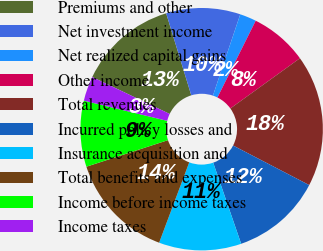Convert chart. <chart><loc_0><loc_0><loc_500><loc_500><pie_chart><fcel>Premiums and other<fcel>Net investment income<fcel>Net realized capital gains<fcel>Other income<fcel>Total revenues<fcel>Incurred policy losses and<fcel>Insurance acquisition and<fcel>Total benefits and expenses<fcel>Income before income taxes<fcel>Income taxes<nl><fcel>13.19%<fcel>9.89%<fcel>2.2%<fcel>7.69%<fcel>17.58%<fcel>12.09%<fcel>10.99%<fcel>14.29%<fcel>8.79%<fcel>3.3%<nl></chart> 